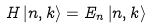Convert formula to latex. <formula><loc_0><loc_0><loc_500><loc_500>H \left | n , k \right \rangle = E _ { n } \left | n , k \right \rangle</formula> 